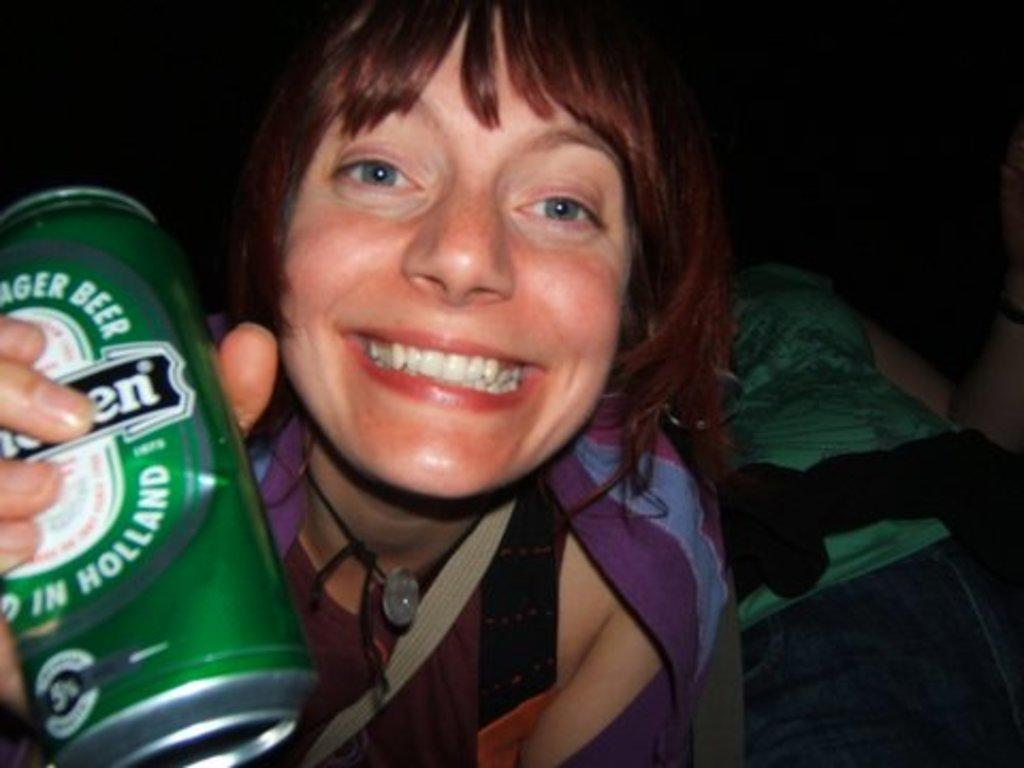Who is present in the image? There is a woman in the image. What is the woman holding in her hand? The woman is holding a tin can in her hand. What is the woman's facial expression in the image? The woman is smiling. What type of blade is the woman using to cut the tin can in the image? There is no blade present in the image, and the woman is not cutting the tin can. 